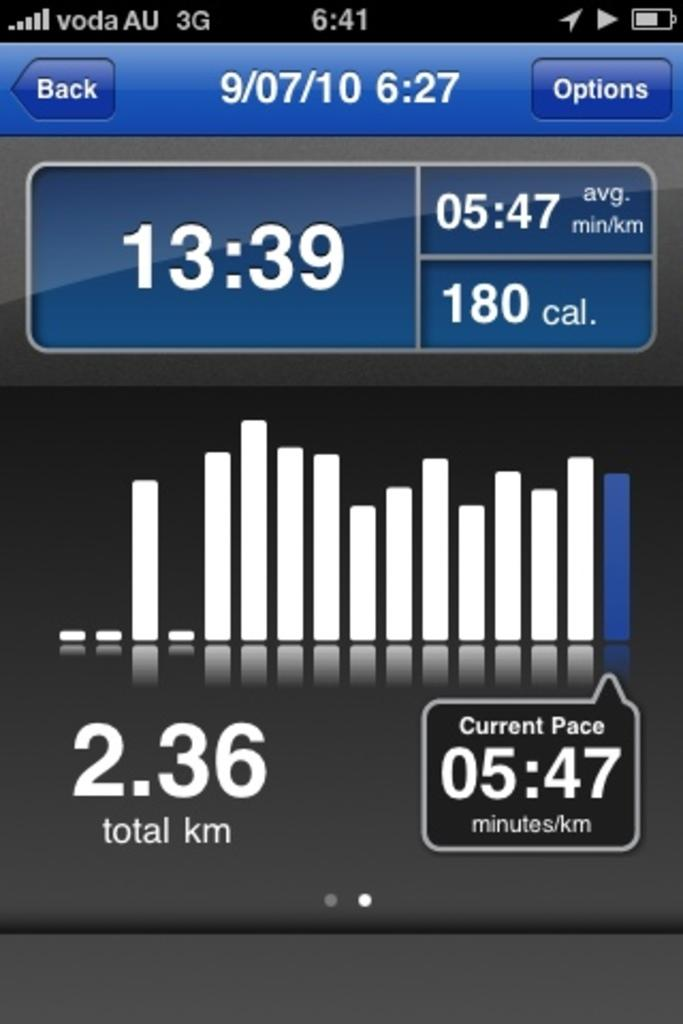<image>
Write a terse but informative summary of the picture. A screen shows an options tab as well as back on the top on either side of the date. 